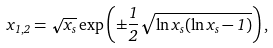Convert formula to latex. <formula><loc_0><loc_0><loc_500><loc_500>x _ { 1 , 2 } = \sqrt { x _ { s } } \exp \left ( \pm \frac { 1 } { 2 } \sqrt { \ln x _ { s } ( \ln x _ { s } - 1 ) } \right ) ,</formula> 